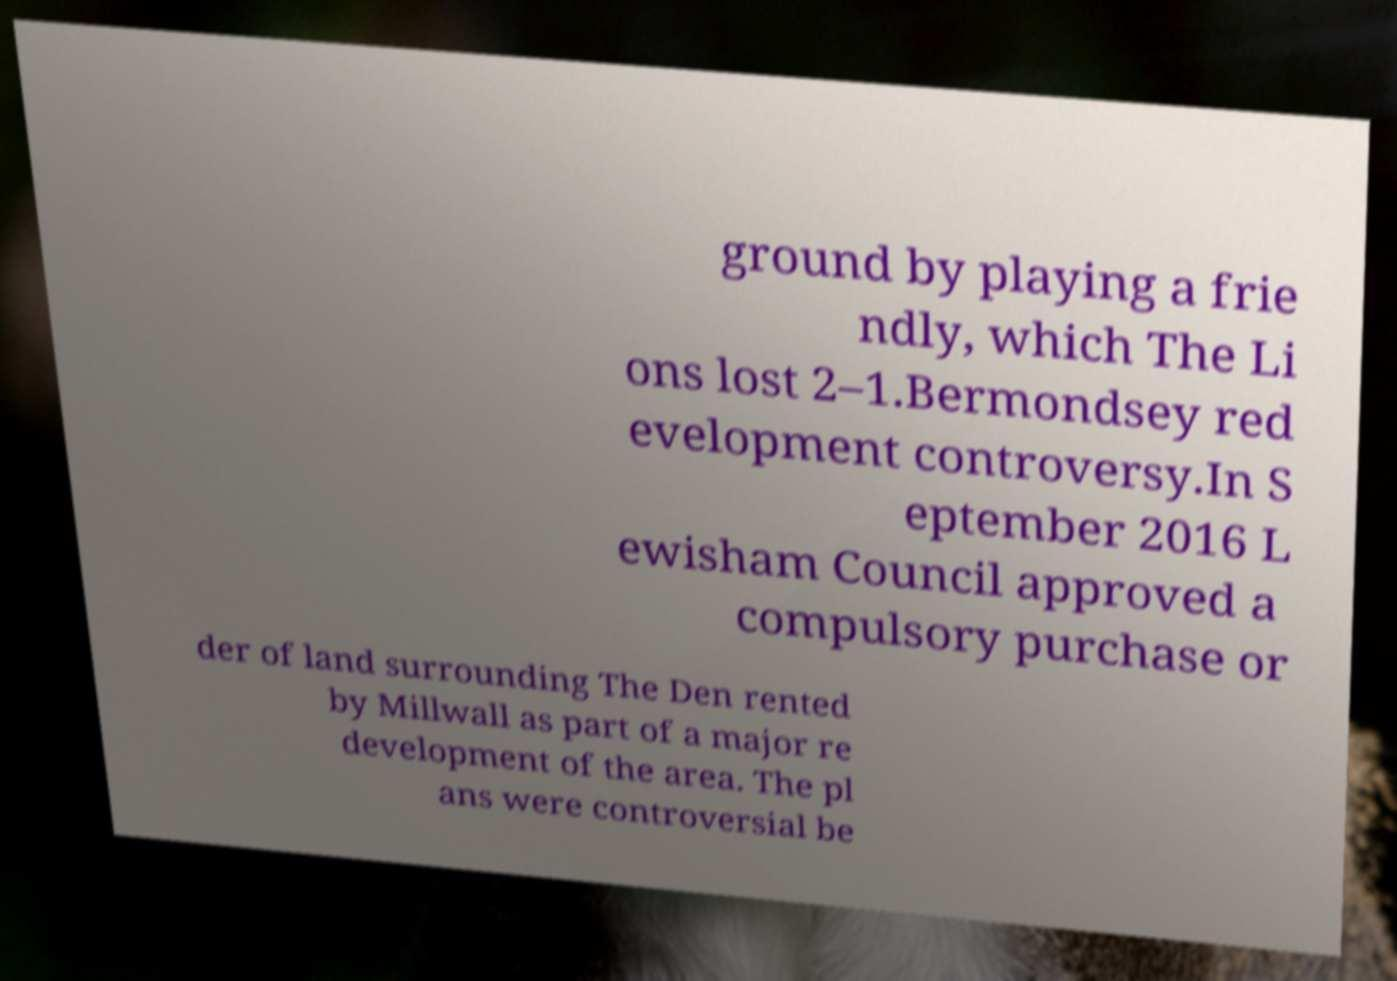For documentation purposes, I need the text within this image transcribed. Could you provide that? ground by playing a frie ndly, which The Li ons lost 2–1.Bermondsey red evelopment controversy.In S eptember 2016 L ewisham Council approved a compulsory purchase or der of land surrounding The Den rented by Millwall as part of a major re development of the area. The pl ans were controversial be 